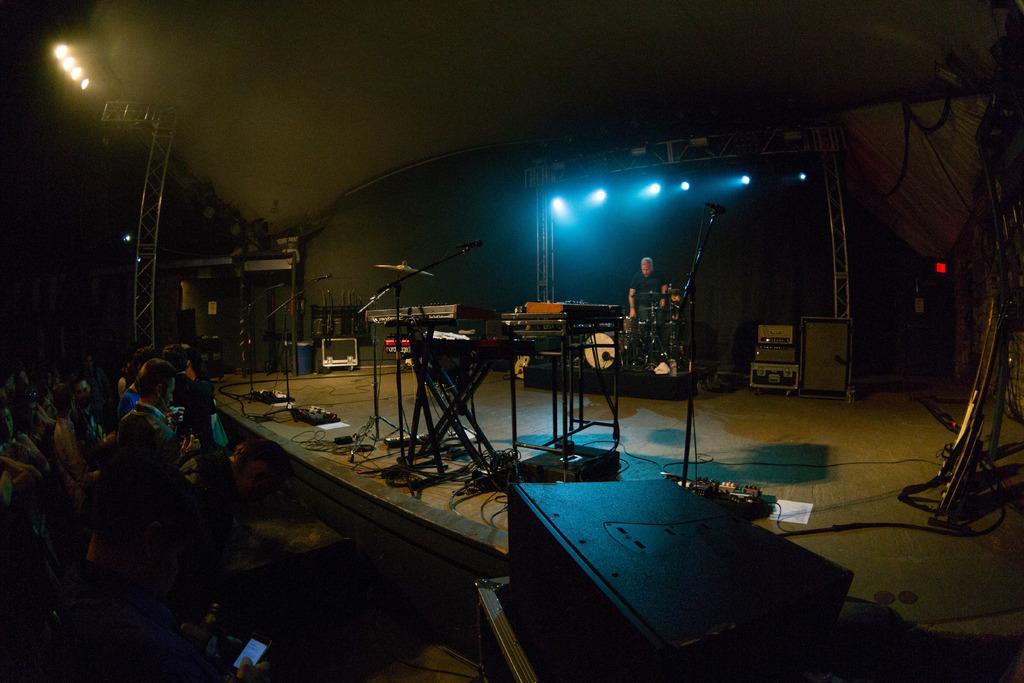Please provide a concise description of this image. In this image we can see person mic and musical instruments on the dais. On the left side of the we can see crowd and lights. In the background we can see lights, poles and wall. At the bottom of the image there is speaker. 